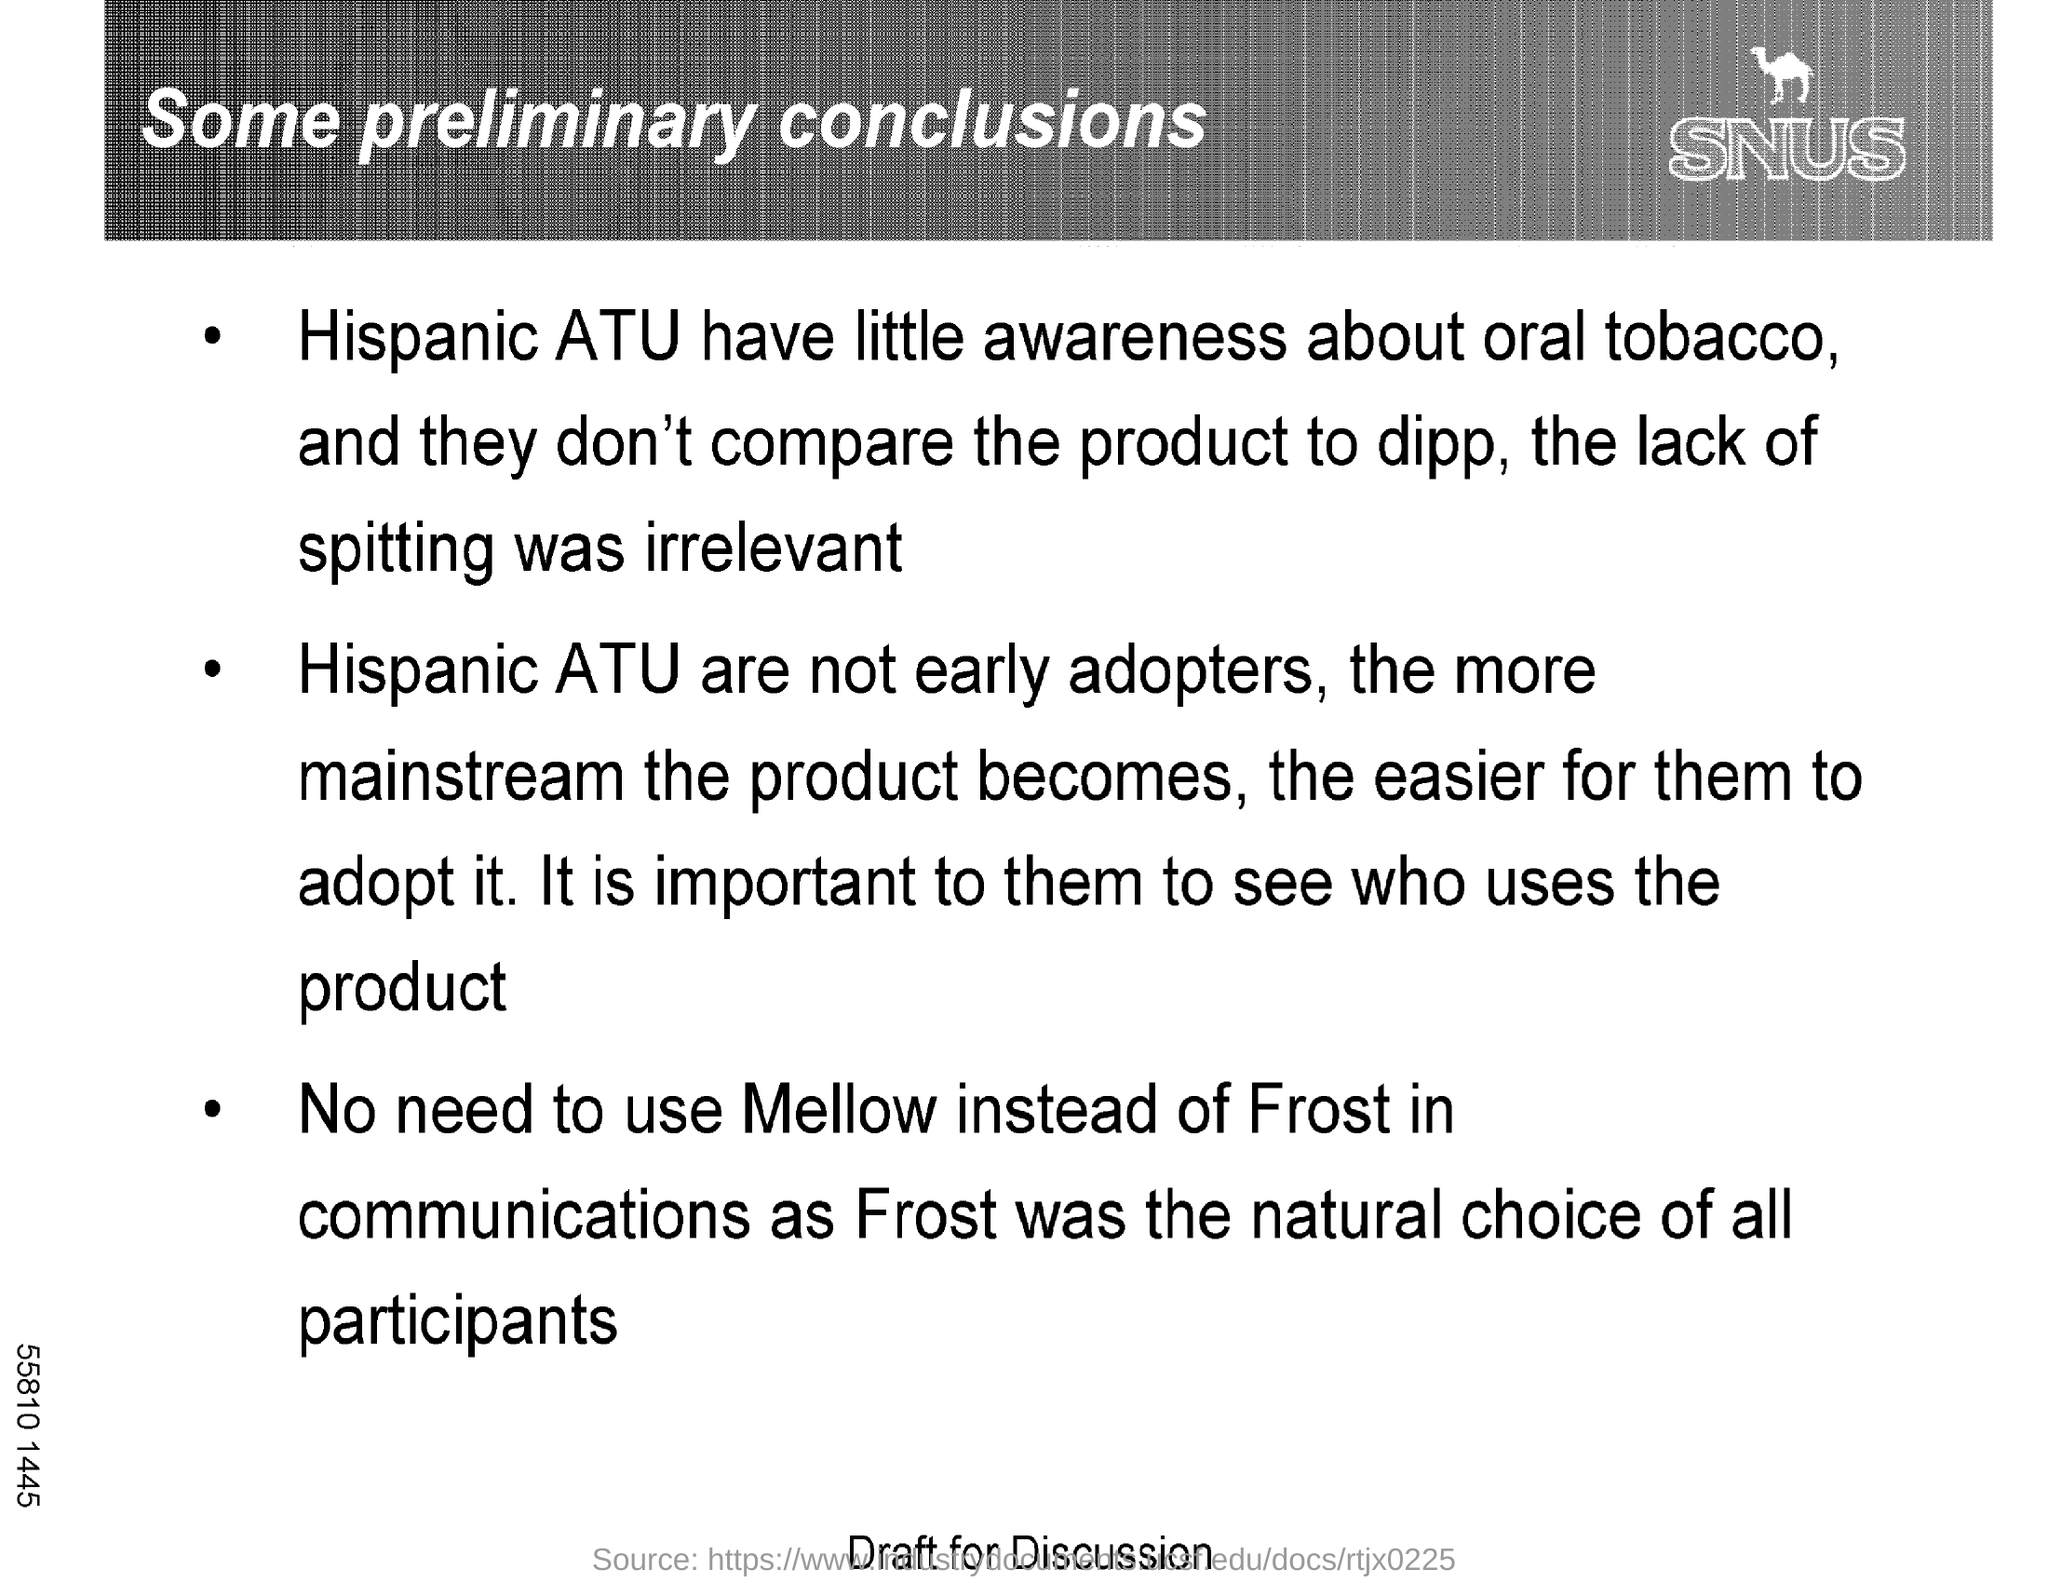Mention a couple of crucial points in this snapshot. The title of the document is 'SOME PRELIMINARY CONCLUSIONS.' The text written below the image is 'SNUS..' 